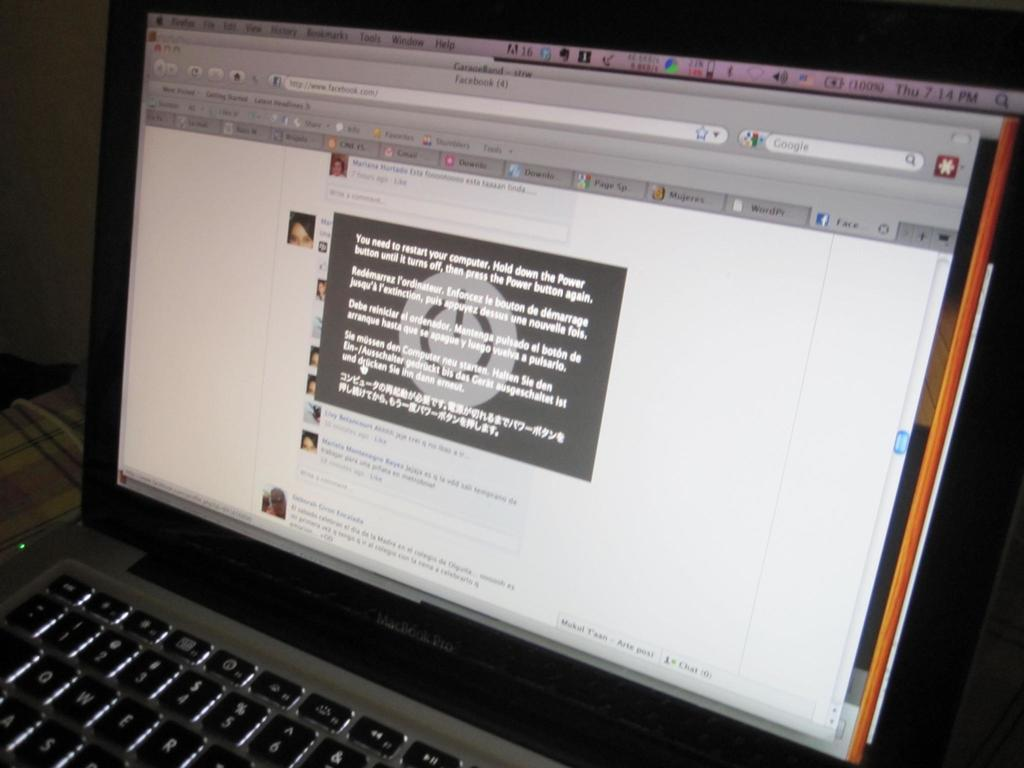<image>
Offer a succinct explanation of the picture presented. A laptop screen is opened to a Facebook page. 